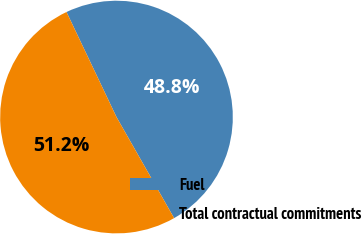Convert chart. <chart><loc_0><loc_0><loc_500><loc_500><pie_chart><fcel>Fuel<fcel>Total contractual commitments<nl><fcel>48.82%<fcel>51.18%<nl></chart> 